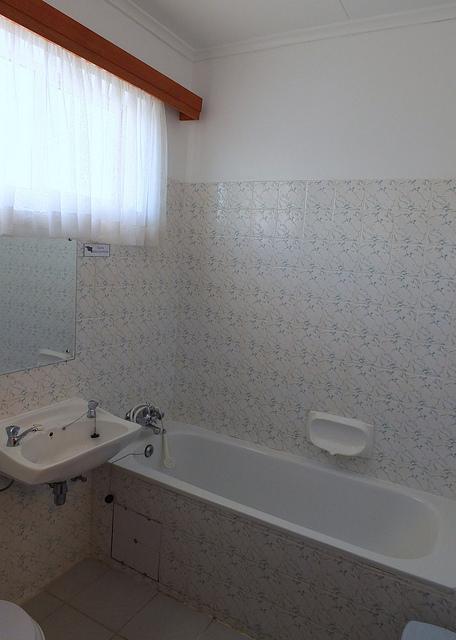How many curtains are hanging from the rod?
Give a very brief answer. 1. 